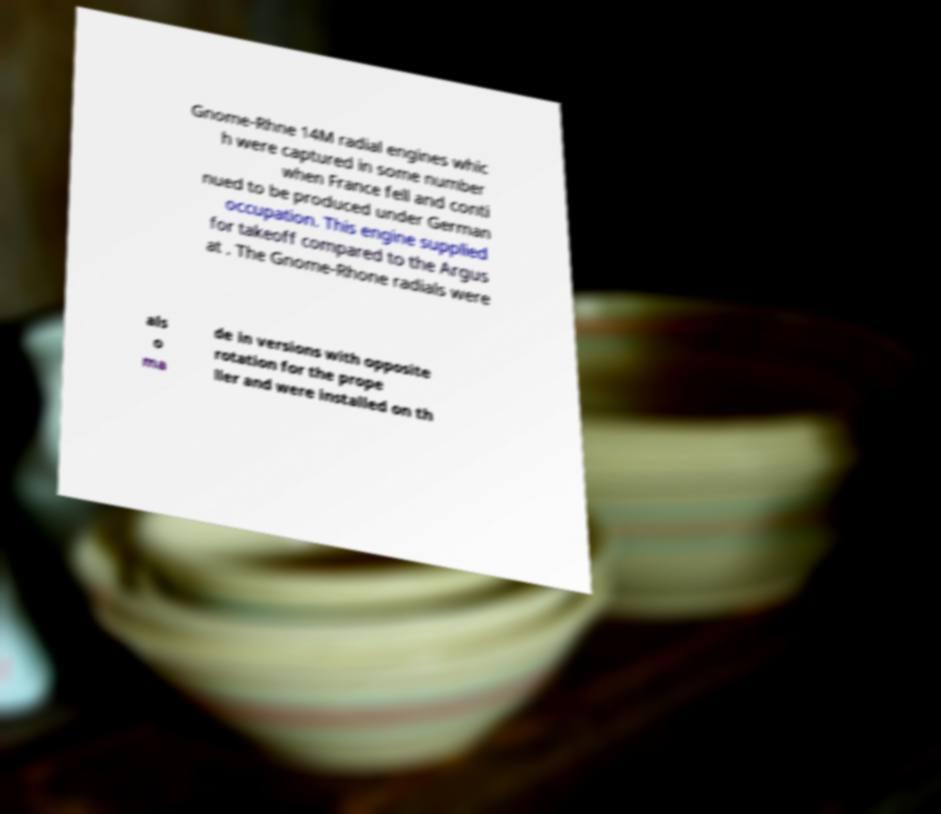Please read and relay the text visible in this image. What does it say? Gnome-Rhne 14M radial engines whic h were captured in some number when France fell and conti nued to be produced under German occupation. This engine supplied for takeoff compared to the Argus at . The Gnome-Rhone radials were als o ma de in versions with opposite rotation for the prope ller and were installed on th 